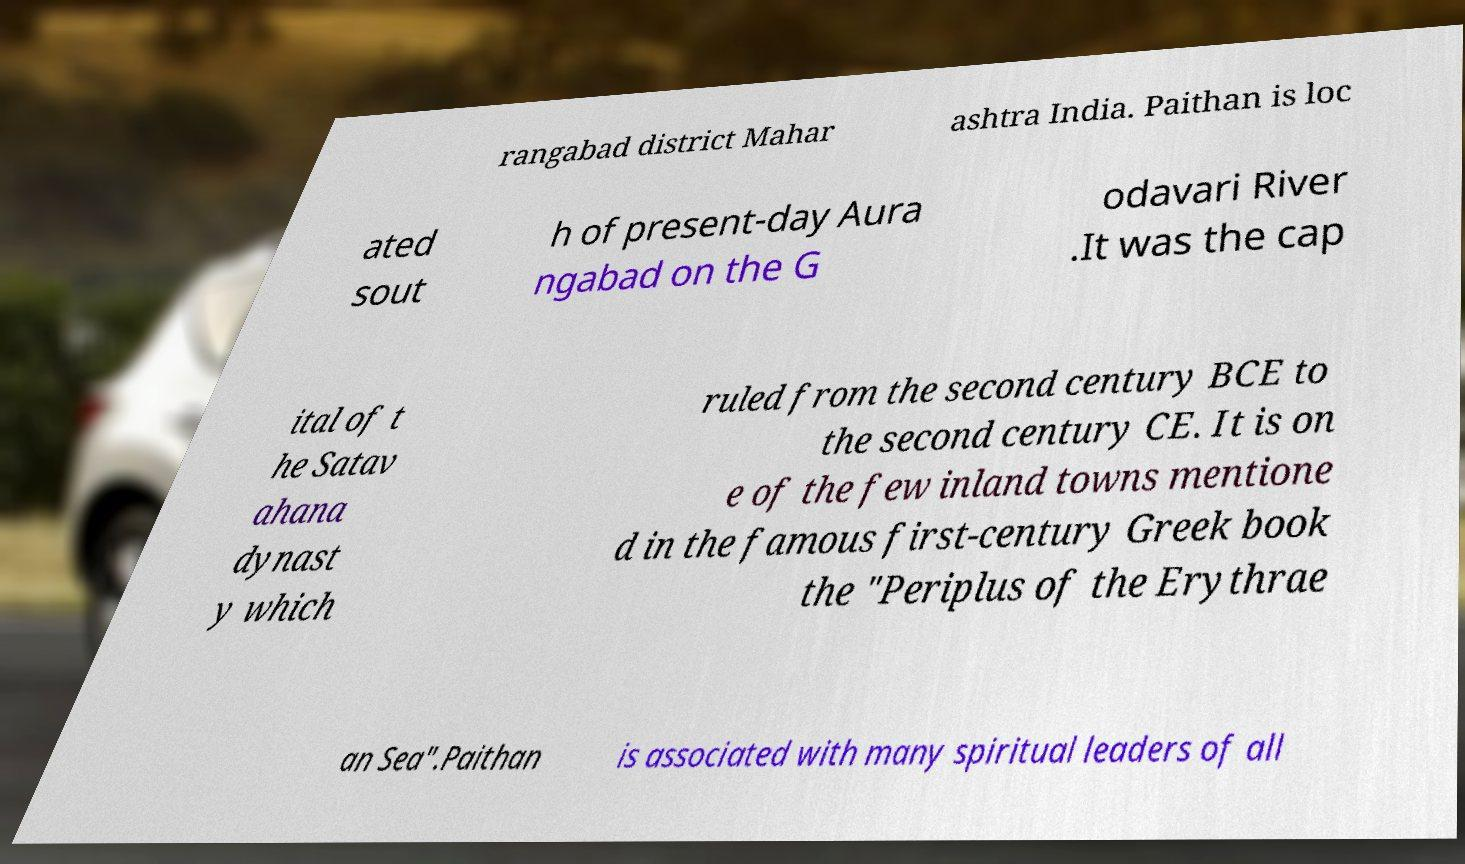What messages or text are displayed in this image? I need them in a readable, typed format. rangabad district Mahar ashtra India. Paithan is loc ated sout h of present-day Aura ngabad on the G odavari River .It was the cap ital of t he Satav ahana dynast y which ruled from the second century BCE to the second century CE. It is on e of the few inland towns mentione d in the famous first-century Greek book the "Periplus of the Erythrae an Sea".Paithan is associated with many spiritual leaders of all 